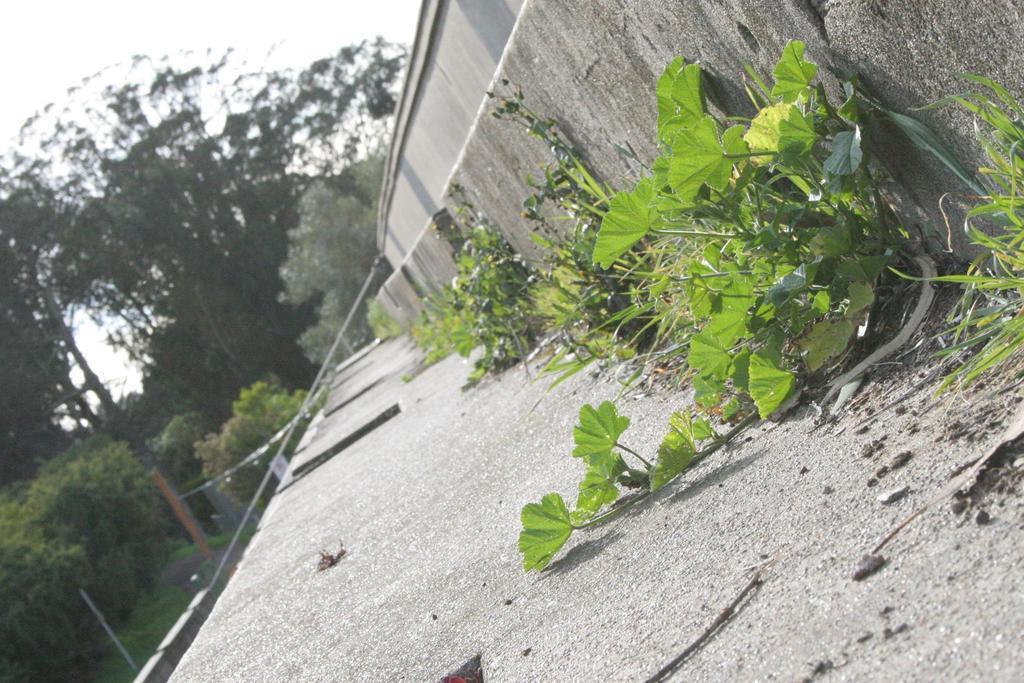How would you summarize this image in a sentence or two? In the foreground of the picture there are plants and cement construction maybe staircase. In the background there are trees, hand railing and sky. 